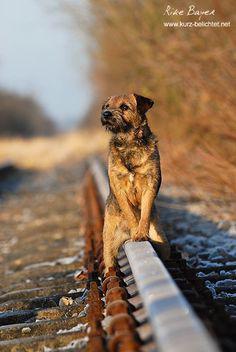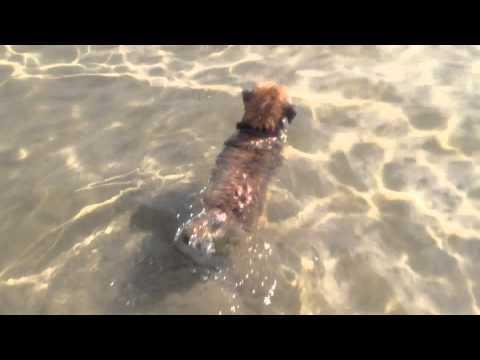The first image is the image on the left, the second image is the image on the right. Assess this claim about the two images: "Only one of the images shows a dog in a scene with water, and that image shows the bottom ground underneath the water.". Correct or not? Answer yes or no. Yes. The first image is the image on the left, the second image is the image on the right. Examine the images to the left and right. Is the description "In the image on the left, there isn't any body of water." accurate? Answer yes or no. Yes. 